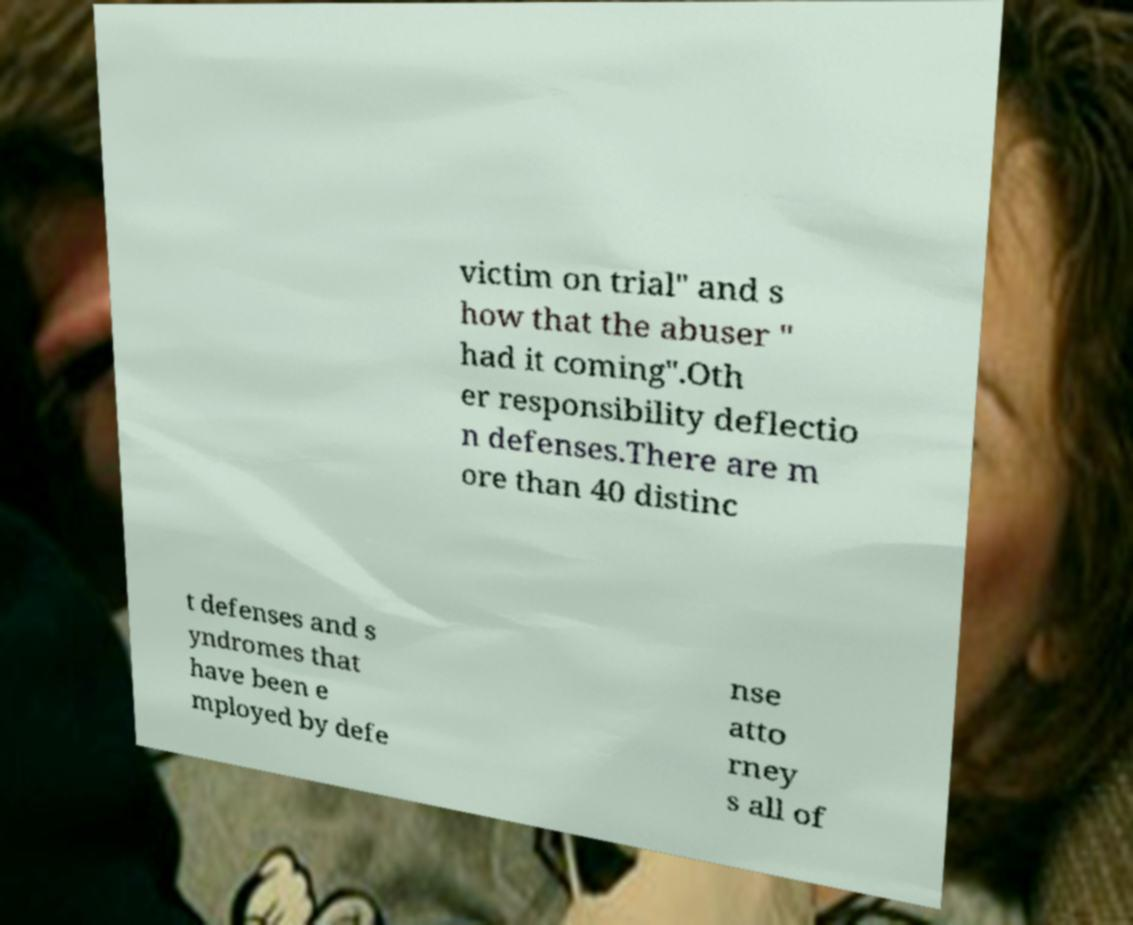Please identify and transcribe the text found in this image. victim on trial" and s how that the abuser " had it coming".Oth er responsibility deflectio n defenses.There are m ore than 40 distinc t defenses and s yndromes that have been e mployed by defe nse atto rney s all of 